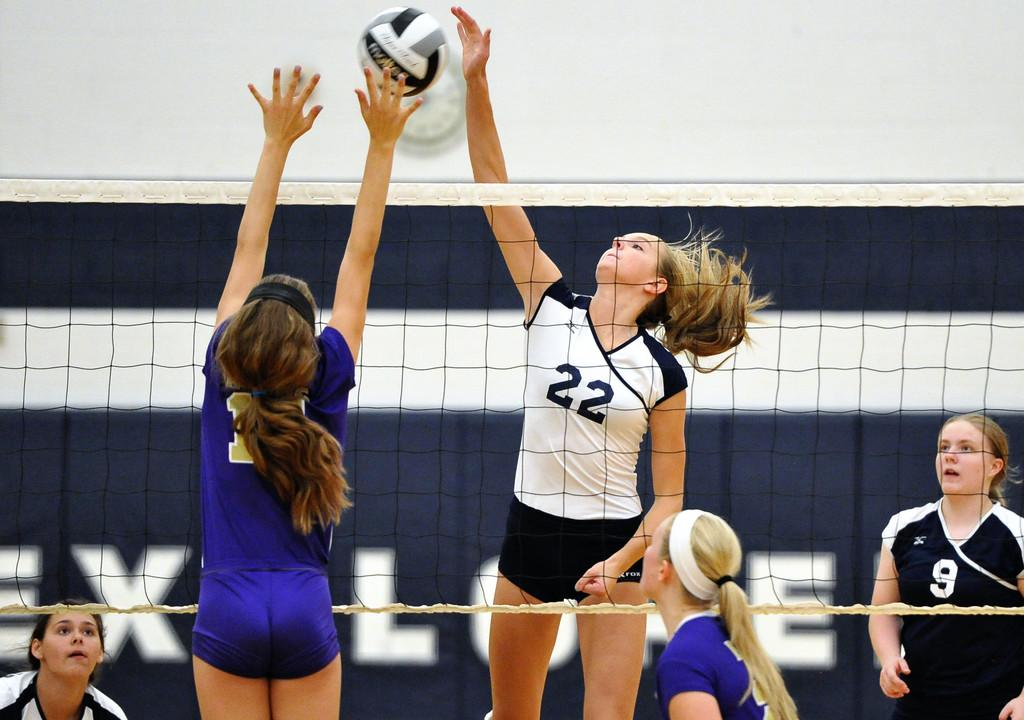<image>
Create a compact narrative representing the image presented. A girl volleyball player in blue uniform attempts to block a spike by no 22 in a white uniform 